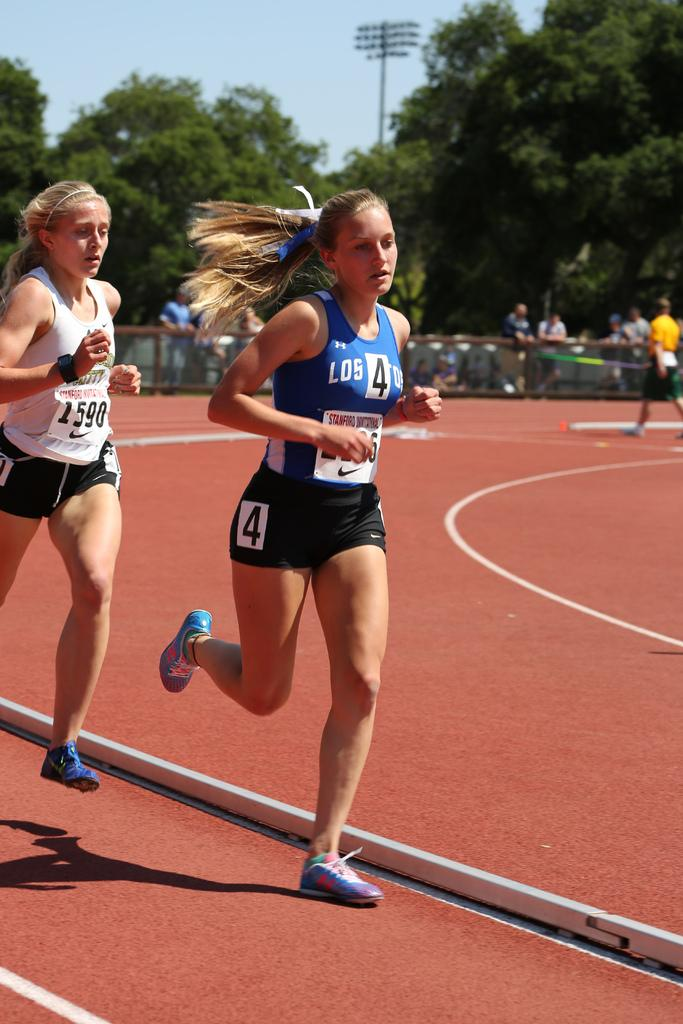<image>
Give a short and clear explanation of the subsequent image. Woman running in a race with a sign taht says the number 4. 